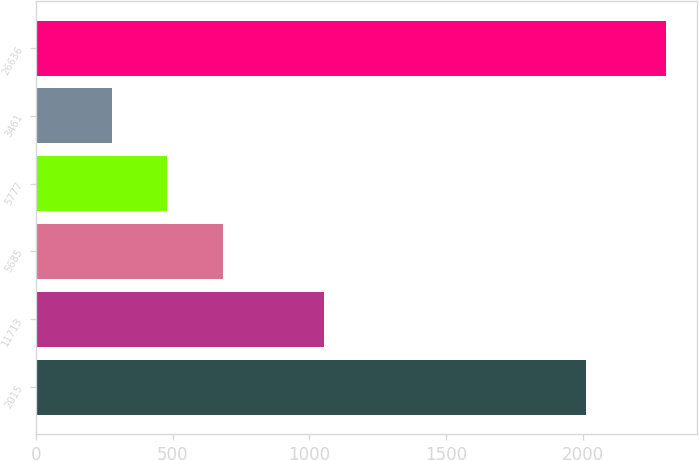<chart> <loc_0><loc_0><loc_500><loc_500><bar_chart><fcel>2015<fcel>11713<fcel>5685<fcel>5777<fcel>3461<fcel>26636<nl><fcel>2013<fcel>1054.5<fcel>682.78<fcel>480.14<fcel>277.5<fcel>2303.9<nl></chart> 